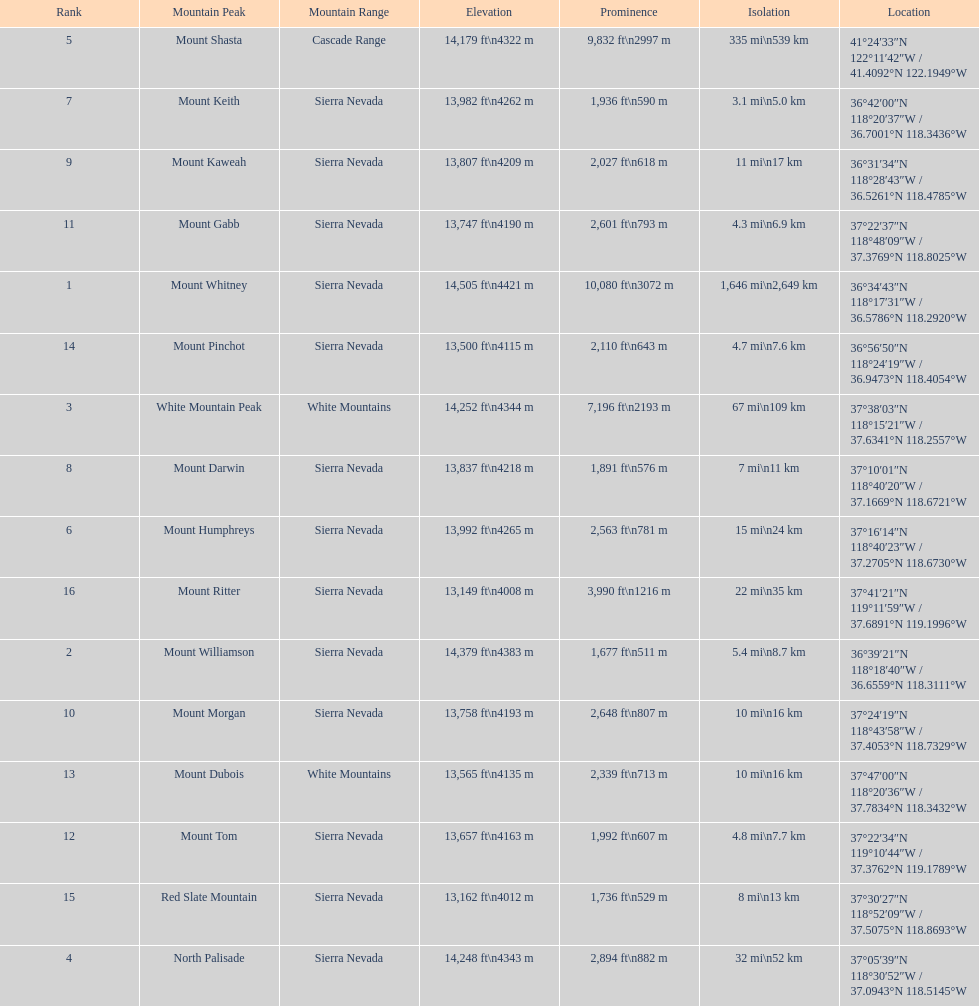What is the next highest mountain peak after north palisade? Mount Shasta. 